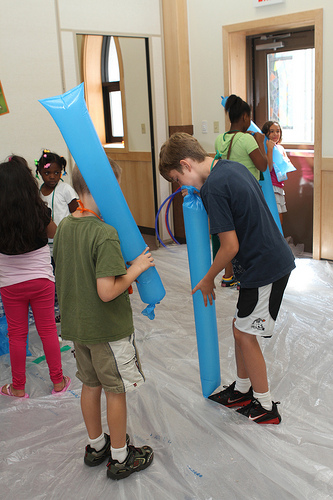<image>
Can you confirm if the boy is in the boy? No. The boy is not contained within the boy. These objects have a different spatial relationship. 